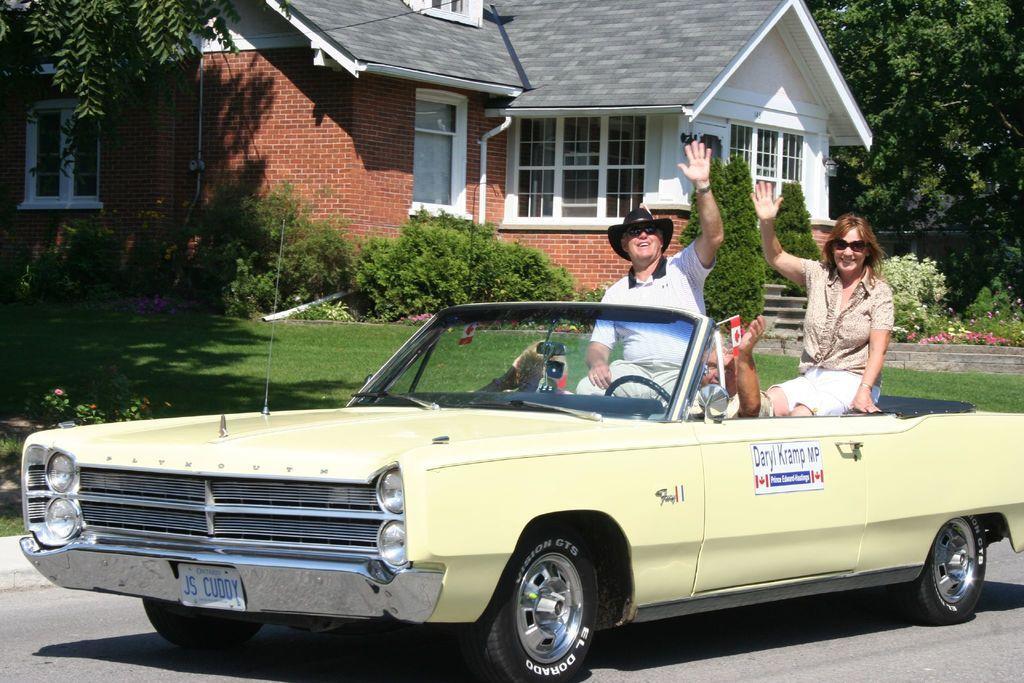Describe this image in one or two sentences. This is a car on the road. Three people are sitting inside the car. In the background there is a house and trees. 